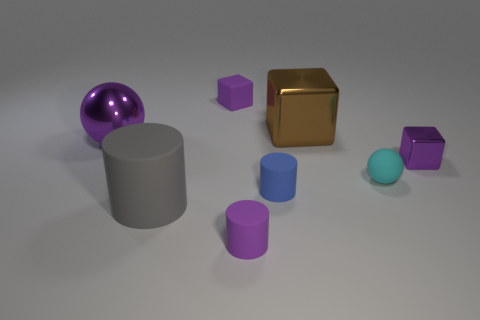How many cylinders are big cyan shiny things or tiny metallic things?
Your answer should be compact. 0. There is a small cylinder that is the same color as the large metallic ball; what is its material?
Your response must be concise. Rubber. There is a shiny ball; does it have the same color as the tiny matte object that is behind the large purple metal object?
Ensure brevity in your answer.  Yes. The small metallic block is what color?
Your answer should be very brief. Purple. How many things are either small green metal balls or matte objects?
Provide a succinct answer. 5. What is the material of the purple thing that is the same size as the brown metal cube?
Your response must be concise. Metal. What is the size of the gray matte cylinder that is in front of the big brown metallic thing?
Offer a very short reply. Large. What is the material of the blue object?
Offer a terse response. Rubber. How many objects are purple shiny objects that are on the right side of the big ball or objects to the left of the tiny sphere?
Offer a very short reply. 7. What number of other objects are the same color as the small rubber cube?
Your response must be concise. 3. 